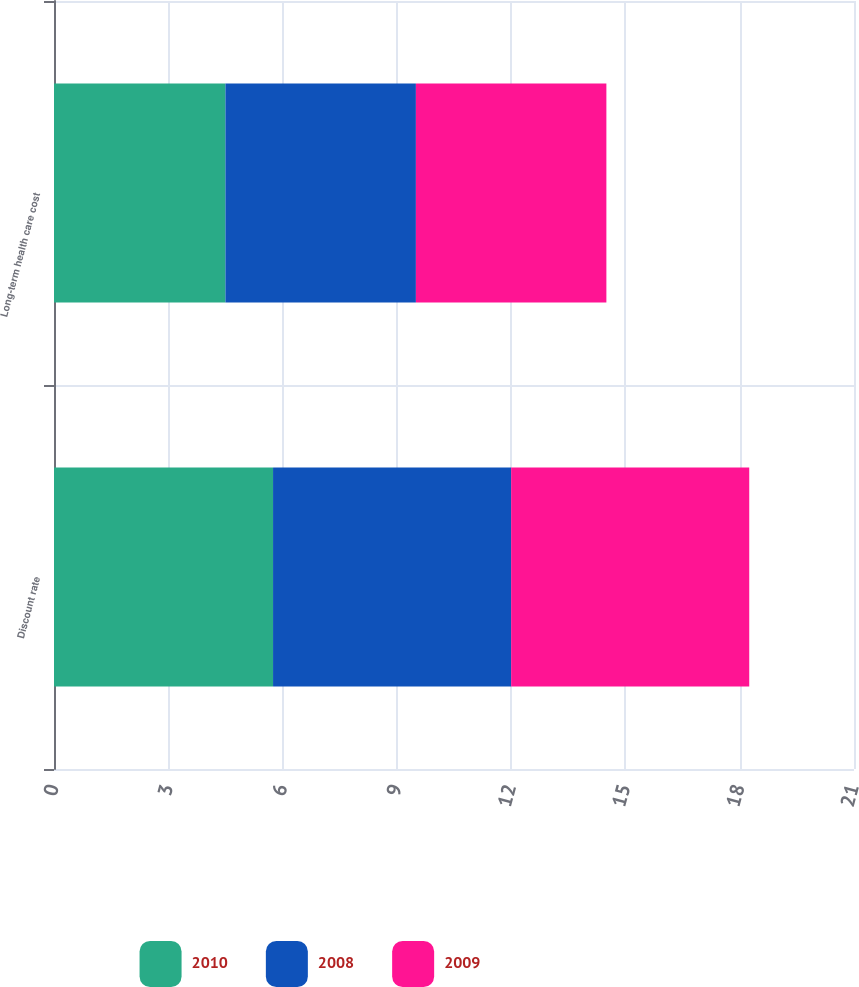Convert chart. <chart><loc_0><loc_0><loc_500><loc_500><stacked_bar_chart><ecel><fcel>Discount rate<fcel>Long-term health care cost<nl><fcel>2010<fcel>5.75<fcel>4.5<nl><fcel>2008<fcel>6.25<fcel>5<nl><fcel>2009<fcel>6.25<fcel>5<nl></chart> 